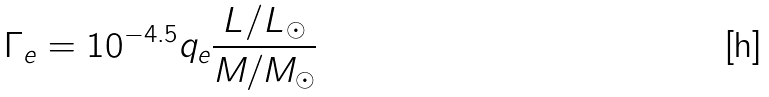Convert formula to latex. <formula><loc_0><loc_0><loc_500><loc_500>\Gamma _ { e } = 1 0 ^ { - 4 . 5 } q _ { e } \frac { L / L _ { \odot } } { M / M _ { \odot } }</formula> 